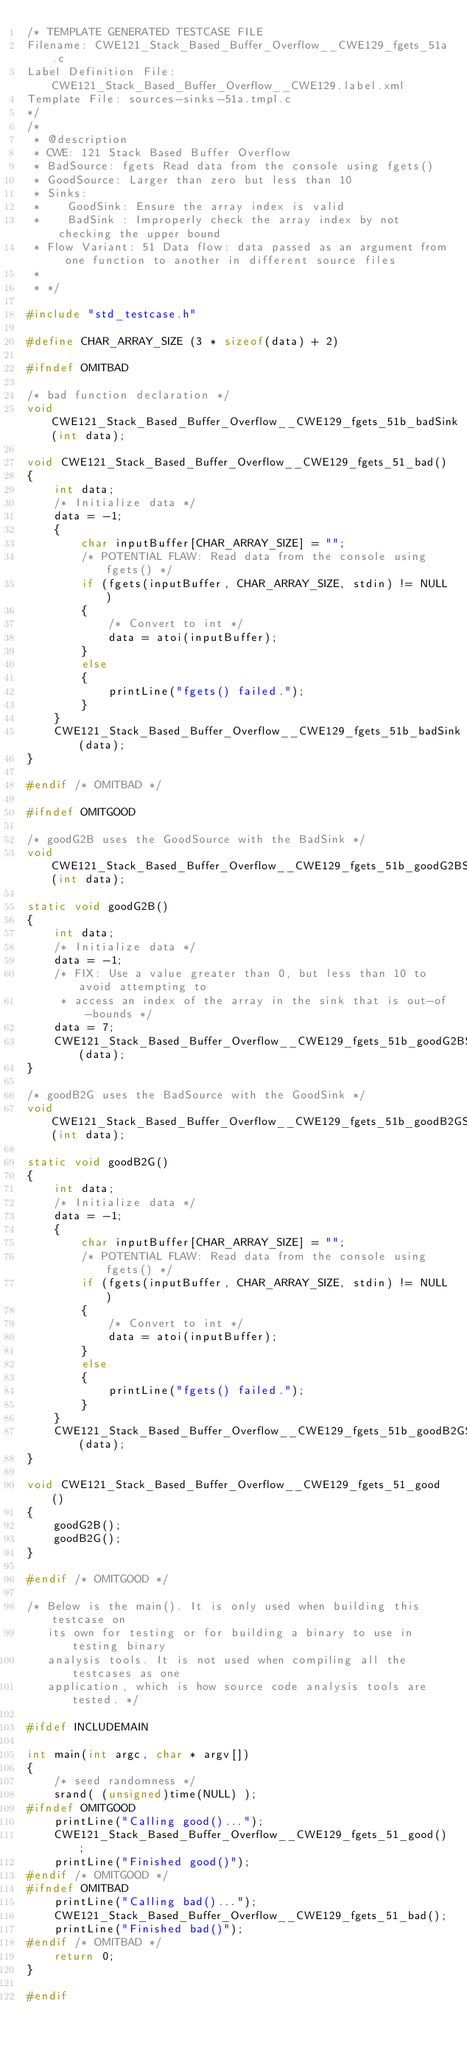Convert code to text. <code><loc_0><loc_0><loc_500><loc_500><_C_>/* TEMPLATE GENERATED TESTCASE FILE
Filename: CWE121_Stack_Based_Buffer_Overflow__CWE129_fgets_51a.c
Label Definition File: CWE121_Stack_Based_Buffer_Overflow__CWE129.label.xml
Template File: sources-sinks-51a.tmpl.c
*/
/*
 * @description
 * CWE: 121 Stack Based Buffer Overflow
 * BadSource: fgets Read data from the console using fgets()
 * GoodSource: Larger than zero but less than 10
 * Sinks:
 *    GoodSink: Ensure the array index is valid
 *    BadSink : Improperly check the array index by not checking the upper bound
 * Flow Variant: 51 Data flow: data passed as an argument from one function to another in different source files
 *
 * */

#include "std_testcase.h"

#define CHAR_ARRAY_SIZE (3 * sizeof(data) + 2)

#ifndef OMITBAD

/* bad function declaration */
void CWE121_Stack_Based_Buffer_Overflow__CWE129_fgets_51b_badSink(int data);

void CWE121_Stack_Based_Buffer_Overflow__CWE129_fgets_51_bad()
{
    int data;
    /* Initialize data */
    data = -1;
    {
        char inputBuffer[CHAR_ARRAY_SIZE] = "";
        /* POTENTIAL FLAW: Read data from the console using fgets() */
        if (fgets(inputBuffer, CHAR_ARRAY_SIZE, stdin) != NULL)
        {
            /* Convert to int */
            data = atoi(inputBuffer);
        }
        else
        {
            printLine("fgets() failed.");
        }
    }
    CWE121_Stack_Based_Buffer_Overflow__CWE129_fgets_51b_badSink(data);
}

#endif /* OMITBAD */

#ifndef OMITGOOD

/* goodG2B uses the GoodSource with the BadSink */
void CWE121_Stack_Based_Buffer_Overflow__CWE129_fgets_51b_goodG2BSink(int data);

static void goodG2B()
{
    int data;
    /* Initialize data */
    data = -1;
    /* FIX: Use a value greater than 0, but less than 10 to avoid attempting to
     * access an index of the array in the sink that is out-of-bounds */
    data = 7;
    CWE121_Stack_Based_Buffer_Overflow__CWE129_fgets_51b_goodG2BSink(data);
}

/* goodB2G uses the BadSource with the GoodSink */
void CWE121_Stack_Based_Buffer_Overflow__CWE129_fgets_51b_goodB2GSink(int data);

static void goodB2G()
{
    int data;
    /* Initialize data */
    data = -1;
    {
        char inputBuffer[CHAR_ARRAY_SIZE] = "";
        /* POTENTIAL FLAW: Read data from the console using fgets() */
        if (fgets(inputBuffer, CHAR_ARRAY_SIZE, stdin) != NULL)
        {
            /* Convert to int */
            data = atoi(inputBuffer);
        }
        else
        {
            printLine("fgets() failed.");
        }
    }
    CWE121_Stack_Based_Buffer_Overflow__CWE129_fgets_51b_goodB2GSink(data);
}

void CWE121_Stack_Based_Buffer_Overflow__CWE129_fgets_51_good()
{
    goodG2B();
    goodB2G();
}

#endif /* OMITGOOD */

/* Below is the main(). It is only used when building this testcase on
   its own for testing or for building a binary to use in testing binary
   analysis tools. It is not used when compiling all the testcases as one
   application, which is how source code analysis tools are tested. */

#ifdef INCLUDEMAIN

int main(int argc, char * argv[])
{
    /* seed randomness */
    srand( (unsigned)time(NULL) );
#ifndef OMITGOOD
    printLine("Calling good()...");
    CWE121_Stack_Based_Buffer_Overflow__CWE129_fgets_51_good();
    printLine("Finished good()");
#endif /* OMITGOOD */
#ifndef OMITBAD
    printLine("Calling bad()...");
    CWE121_Stack_Based_Buffer_Overflow__CWE129_fgets_51_bad();
    printLine("Finished bad()");
#endif /* OMITBAD */
    return 0;
}

#endif
</code> 